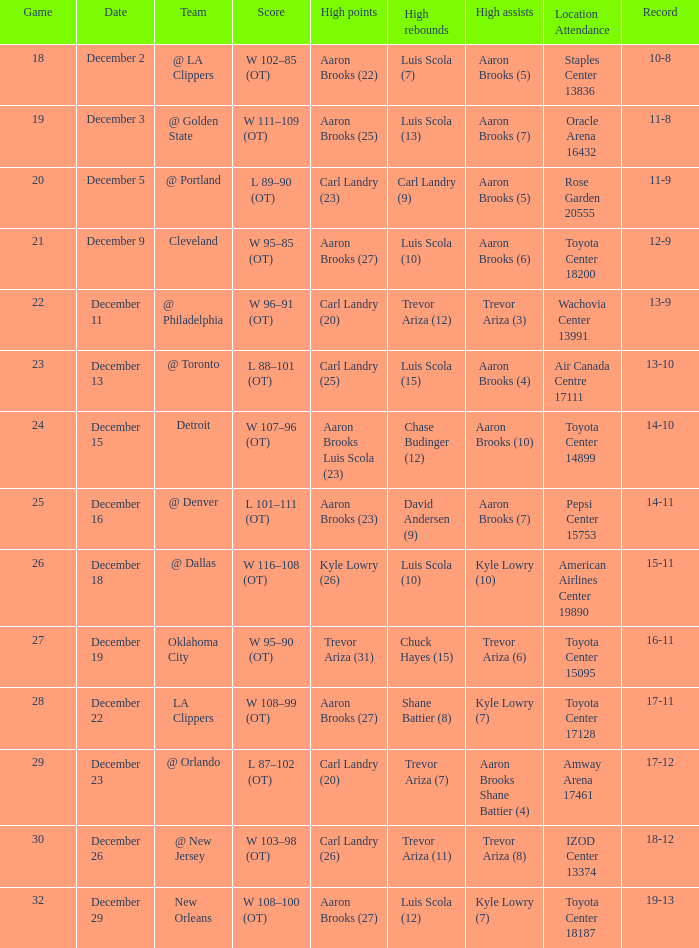In the match where carl landry (23) achieved his highest points, who managed to secure the highest number of rebounds? Carl Landry (9). Can you give me this table as a dict? {'header': ['Game', 'Date', 'Team', 'Score', 'High points', 'High rebounds', 'High assists', 'Location Attendance', 'Record'], 'rows': [['18', 'December 2', '@ LA Clippers', 'W 102–85 (OT)', 'Aaron Brooks (22)', 'Luis Scola (7)', 'Aaron Brooks (5)', 'Staples Center 13836', '10-8'], ['19', 'December 3', '@ Golden State', 'W 111–109 (OT)', 'Aaron Brooks (25)', 'Luis Scola (13)', 'Aaron Brooks (7)', 'Oracle Arena 16432', '11-8'], ['20', 'December 5', '@ Portland', 'L 89–90 (OT)', 'Carl Landry (23)', 'Carl Landry (9)', 'Aaron Brooks (5)', 'Rose Garden 20555', '11-9'], ['21', 'December 9', 'Cleveland', 'W 95–85 (OT)', 'Aaron Brooks (27)', 'Luis Scola (10)', 'Aaron Brooks (6)', 'Toyota Center 18200', '12-9'], ['22', 'December 11', '@ Philadelphia', 'W 96–91 (OT)', 'Carl Landry (20)', 'Trevor Ariza (12)', 'Trevor Ariza (3)', 'Wachovia Center 13991', '13-9'], ['23', 'December 13', '@ Toronto', 'L 88–101 (OT)', 'Carl Landry (25)', 'Luis Scola (15)', 'Aaron Brooks (4)', 'Air Canada Centre 17111', '13-10'], ['24', 'December 15', 'Detroit', 'W 107–96 (OT)', 'Aaron Brooks Luis Scola (23)', 'Chase Budinger (12)', 'Aaron Brooks (10)', 'Toyota Center 14899', '14-10'], ['25', 'December 16', '@ Denver', 'L 101–111 (OT)', 'Aaron Brooks (23)', 'David Andersen (9)', 'Aaron Brooks (7)', 'Pepsi Center 15753', '14-11'], ['26', 'December 18', '@ Dallas', 'W 116–108 (OT)', 'Kyle Lowry (26)', 'Luis Scola (10)', 'Kyle Lowry (10)', 'American Airlines Center 19890', '15-11'], ['27', 'December 19', 'Oklahoma City', 'W 95–90 (OT)', 'Trevor Ariza (31)', 'Chuck Hayes (15)', 'Trevor Ariza (6)', 'Toyota Center 15095', '16-11'], ['28', 'December 22', 'LA Clippers', 'W 108–99 (OT)', 'Aaron Brooks (27)', 'Shane Battier (8)', 'Kyle Lowry (7)', 'Toyota Center 17128', '17-11'], ['29', 'December 23', '@ Orlando', 'L 87–102 (OT)', 'Carl Landry (20)', 'Trevor Ariza (7)', 'Aaron Brooks Shane Battier (4)', 'Amway Arena 17461', '17-12'], ['30', 'December 26', '@ New Jersey', 'W 103–98 (OT)', 'Carl Landry (26)', 'Trevor Ariza (11)', 'Trevor Ariza (8)', 'IZOD Center 13374', '18-12'], ['32', 'December 29', 'New Orleans', 'W 108–100 (OT)', 'Aaron Brooks (27)', 'Luis Scola (12)', 'Kyle Lowry (7)', 'Toyota Center 18187', '19-13']]} 